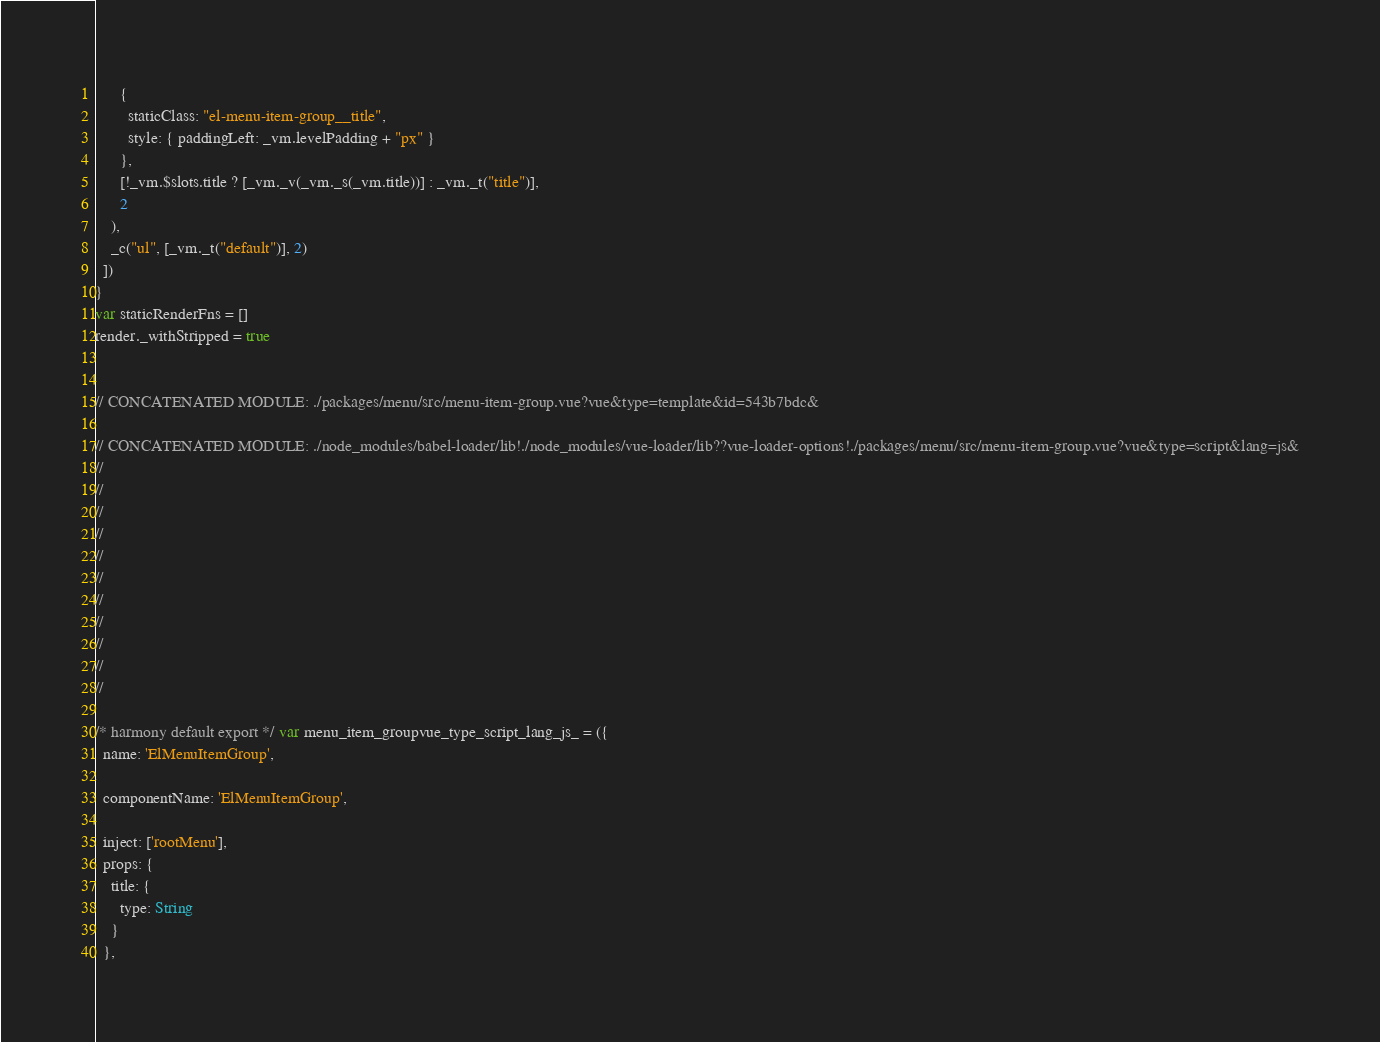Convert code to text. <code><loc_0><loc_0><loc_500><loc_500><_JavaScript_>      {
        staticClass: "el-menu-item-group__title",
        style: { paddingLeft: _vm.levelPadding + "px" }
      },
      [!_vm.$slots.title ? [_vm._v(_vm._s(_vm.title))] : _vm._t("title")],
      2
    ),
    _c("ul", [_vm._t("default")], 2)
  ])
}
var staticRenderFns = []
render._withStripped = true


// CONCATENATED MODULE: ./packages/menu/src/menu-item-group.vue?vue&type=template&id=543b7bdc&

// CONCATENATED MODULE: ./node_modules/babel-loader/lib!./node_modules/vue-loader/lib??vue-loader-options!./packages/menu/src/menu-item-group.vue?vue&type=script&lang=js&
//
//
//
//
//
//
//
//
//
//
//

/* harmony default export */ var menu_item_groupvue_type_script_lang_js_ = ({
  name: 'ElMenuItemGroup',

  componentName: 'ElMenuItemGroup',

  inject: ['rootMenu'],
  props: {
    title: {
      type: String
    }
  },</code> 